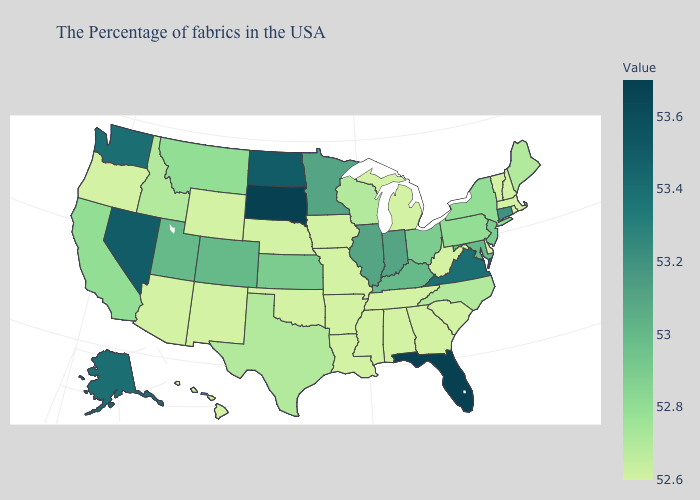Does Nevada have the highest value in the West?
Quick response, please. Yes. Does South Dakota have the highest value in the USA?
Be succinct. Yes. Which states have the highest value in the USA?
Write a very short answer. Florida, South Dakota. Does the map have missing data?
Short answer required. No. Which states hav the highest value in the South?
Concise answer only. Florida. Does Florida have the highest value in the USA?
Concise answer only. Yes. Among the states that border Alabama , which have the lowest value?
Short answer required. Georgia, Tennessee, Mississippi. Among the states that border Nevada , which have the highest value?
Answer briefly. Utah. Does Kentucky have a higher value than Connecticut?
Quick response, please. No. 